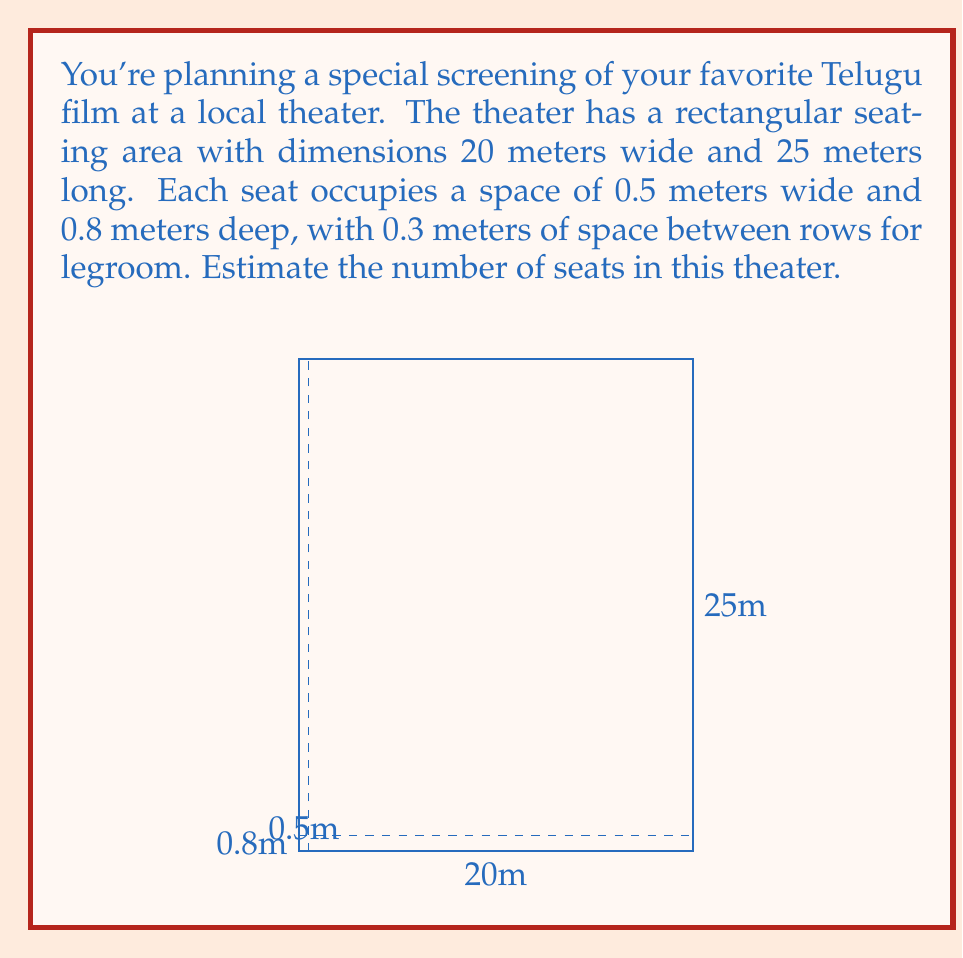Teach me how to tackle this problem. Let's approach this step-by-step:

1) First, calculate the number of seats in a row:
   - Width of theater: 20 meters
   - Width of each seat: 0.5 meters
   - Number of seats per row = $\frac{20}{0.5} = 40$ seats

2) Now, calculate the number of rows:
   - Length of theater: 25 meters
   - Depth of each seat + legroom: $0.8 + 0.3 = 1.1$ meters
   - Number of rows = $\frac{25}{1.1} \approx 22.73$ rows

3) Since we can't have a partial row, we round down to 22 rows.

4) Calculate the total number of seats:
   - Total seats = Number of seats per row × Number of rows
   - Total seats = $40 \times 22 = 880$ seats

Therefore, the estimated number of seats in the theater is 880.
Answer: 880 seats 